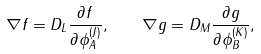Convert formula to latex. <formula><loc_0><loc_0><loc_500><loc_500>\nabla f = D _ { L } { \frac { \partial f } { \partial \phi _ { A } ^ { ( J ) } } } , \quad \nabla g = D _ { M } { \frac { \partial g } { \partial \phi _ { B } ^ { ( K ) } } } ,</formula> 